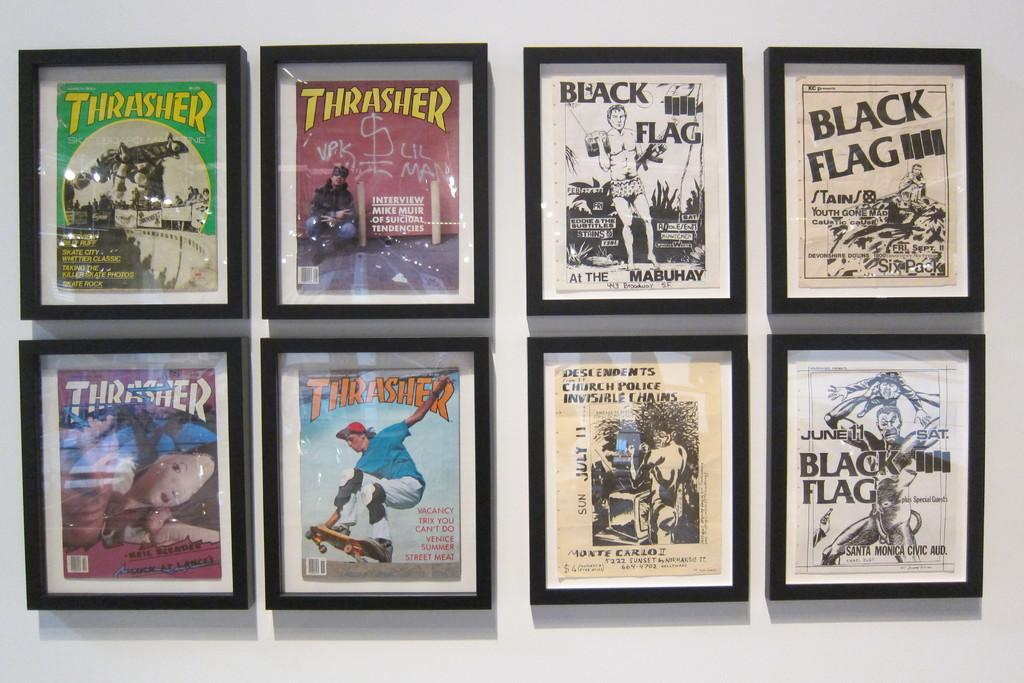<image>
Describe the image concisely. Four posters are displayed on a wall included a couple with the headline Thrasher. 